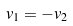Convert formula to latex. <formula><loc_0><loc_0><loc_500><loc_500>v _ { 1 } = - v _ { 2 }</formula> 